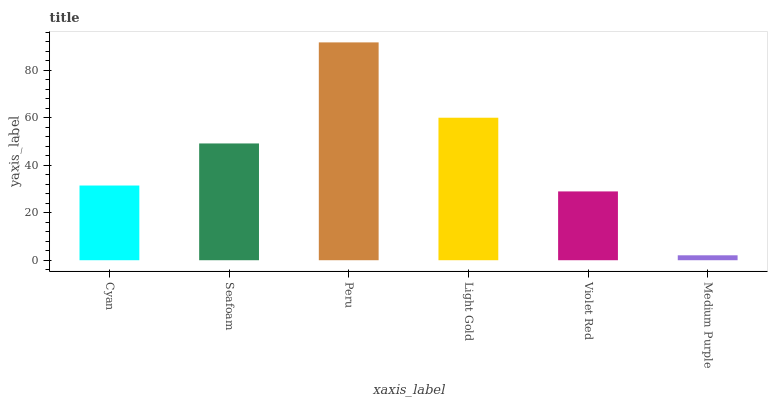Is Medium Purple the minimum?
Answer yes or no. Yes. Is Peru the maximum?
Answer yes or no. Yes. Is Seafoam the minimum?
Answer yes or no. No. Is Seafoam the maximum?
Answer yes or no. No. Is Seafoam greater than Cyan?
Answer yes or no. Yes. Is Cyan less than Seafoam?
Answer yes or no. Yes. Is Cyan greater than Seafoam?
Answer yes or no. No. Is Seafoam less than Cyan?
Answer yes or no. No. Is Seafoam the high median?
Answer yes or no. Yes. Is Cyan the low median?
Answer yes or no. Yes. Is Light Gold the high median?
Answer yes or no. No. Is Medium Purple the low median?
Answer yes or no. No. 